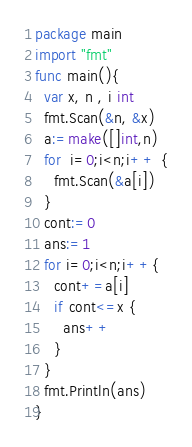<code> <loc_0><loc_0><loc_500><loc_500><_Go_>package main
import "fmt"
func main(){
  var x, n , i int
  fmt.Scan(&n, &x)
  a:=make([]int,n)
  for  i=0;i<n;i++ {
    fmt.Scan(&a[i])
  }
  cont:=0
  ans:=1
  for i=0;i<n;i++{
    cont+=a[i]
    if cont<=x {
      ans++
    }
  }
  fmt.Println(ans)
}
</code> 